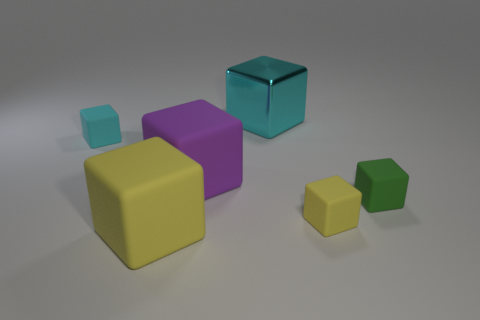Subtract all yellow blocks. How many blocks are left? 4 Subtract all green cubes. How many cubes are left? 5 Subtract 2 cubes. How many cubes are left? 4 Subtract all purple cubes. Subtract all red balls. How many cubes are left? 5 Add 3 matte things. How many objects exist? 9 Add 6 purple blocks. How many purple blocks exist? 7 Subtract 0 gray spheres. How many objects are left? 6 Subtract all small brown blocks. Subtract all cyan things. How many objects are left? 4 Add 3 small cyan matte objects. How many small cyan matte objects are left? 4 